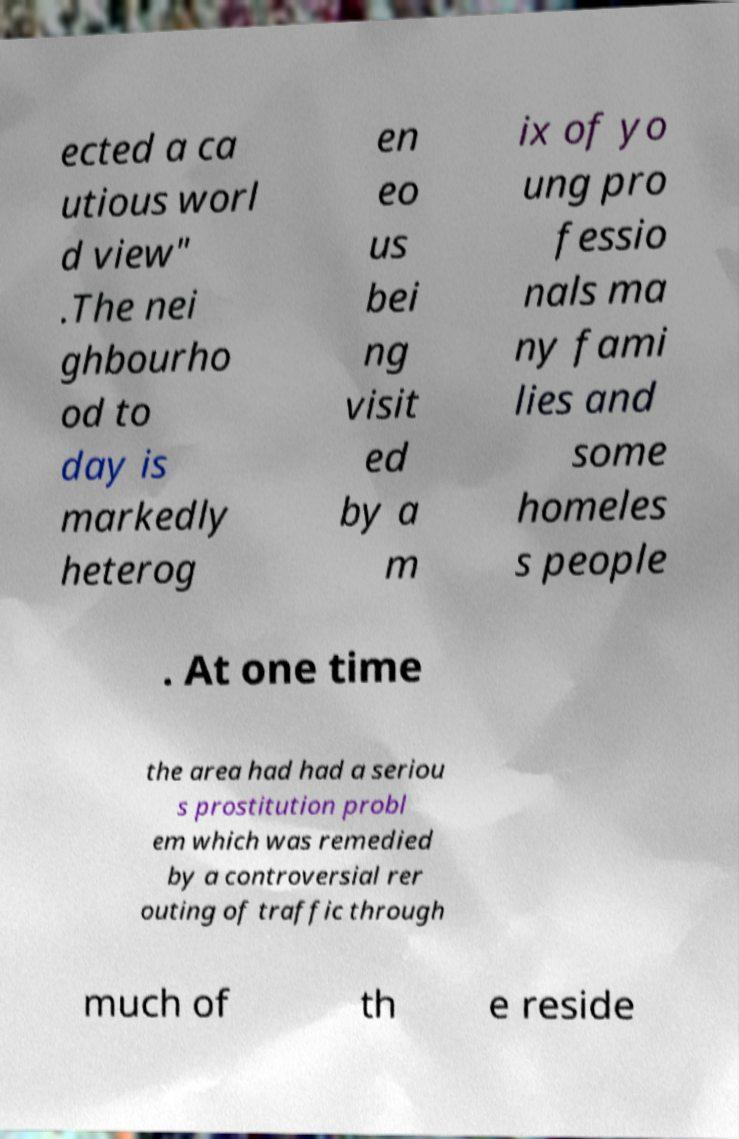For documentation purposes, I need the text within this image transcribed. Could you provide that? ected a ca utious worl d view" .The nei ghbourho od to day is markedly heterog en eo us bei ng visit ed by a m ix of yo ung pro fessio nals ma ny fami lies and some homeles s people . At one time the area had had a seriou s prostitution probl em which was remedied by a controversial rer outing of traffic through much of th e reside 